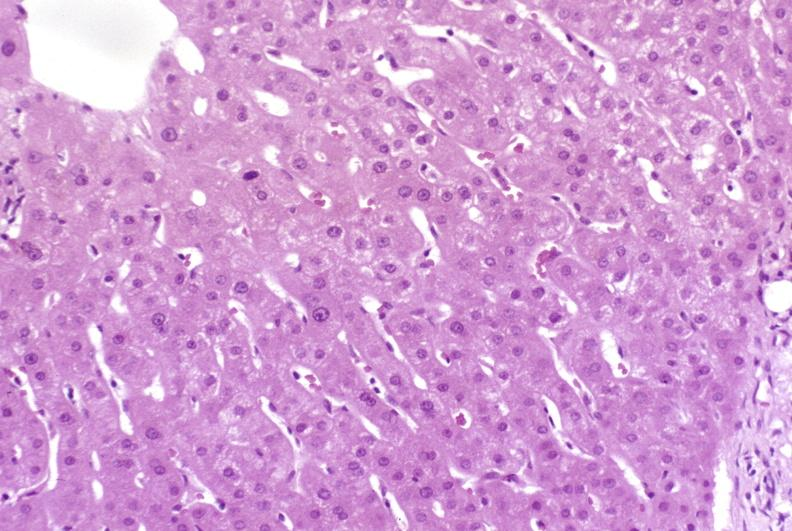s stress present?
Answer the question using a single word or phrase. No 